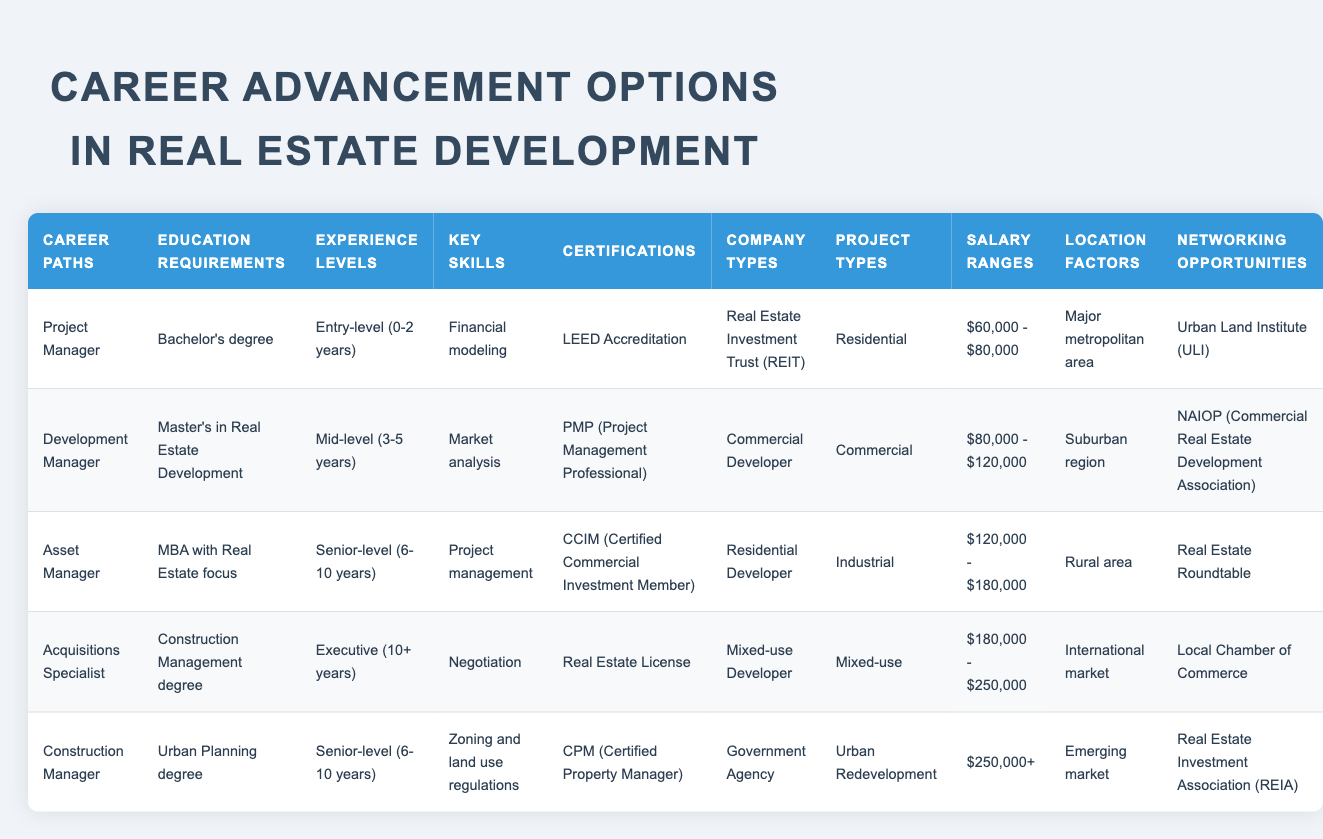What is the education requirement for a Development Manager? The table indicates that the education requirement for a Development Manager is a Master's in Real Estate Development.
Answer: Master's in Real Estate Development Which career paths require a Bachelor's degree? According to the table, the Project Manager position requires a Bachelor's degree, as it is the only career listed with this requirement.
Answer: Project Manager Is a Real Estate License required for an Acquisitions Specialist? Yes, the table confirms that a Real Estate License is one of the certifications needed for an Acquisitions Specialist.
Answer: Yes What is the salary range for an Asset Manager? The salary range for an Asset Manager, as per the table, is between $120,000 and $180,000.
Answer: $120,000 - $180,000 Which career path has the highest salary range among the options provided? The Construction Manager has the highest salary range listed in the table, which is $250,000 and above.
Answer: $250,000+ What common skill do both the Asset Manager and Development Manager positions require? Both positions require the skill of Project management, as indicated in their respective rows in the table.
Answer: Project management How many years of experience are needed for a Construction Manager? According to the table, a Construction Manager requires 6-10 years of experience, which designates it as a senior-level position.
Answer: 6-10 years Which career paths are linked to Mixed-use projects? The table shows that both the Acquisitions Specialist and Construction Manager are linked to Mixed-use projects, as their project types include Mixed-use.
Answer: Acquisitions Specialist, Construction Manager What is the average salary range for Mid-level positions? The salary ranges for mid-level positions (e.g., Development Manager) indicated are $80,000 - $120,000, while another applies to the Entry-level at $60,000 - $80,000. However, only Development Manager is mid-level, so the average remains as stated for that position.
Answer: $80,000 - $120,000 